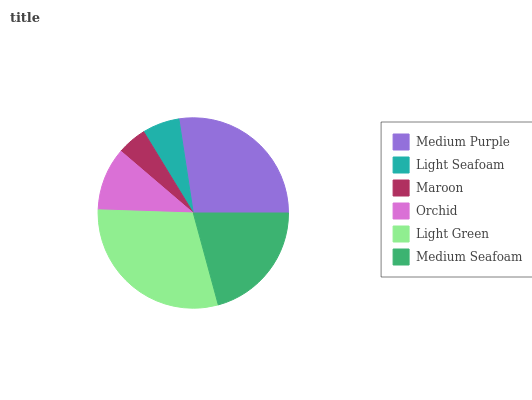Is Maroon the minimum?
Answer yes or no. Yes. Is Light Green the maximum?
Answer yes or no. Yes. Is Light Seafoam the minimum?
Answer yes or no. No. Is Light Seafoam the maximum?
Answer yes or no. No. Is Medium Purple greater than Light Seafoam?
Answer yes or no. Yes. Is Light Seafoam less than Medium Purple?
Answer yes or no. Yes. Is Light Seafoam greater than Medium Purple?
Answer yes or no. No. Is Medium Purple less than Light Seafoam?
Answer yes or no. No. Is Medium Seafoam the high median?
Answer yes or no. Yes. Is Orchid the low median?
Answer yes or no. Yes. Is Orchid the high median?
Answer yes or no. No. Is Light Seafoam the low median?
Answer yes or no. No. 